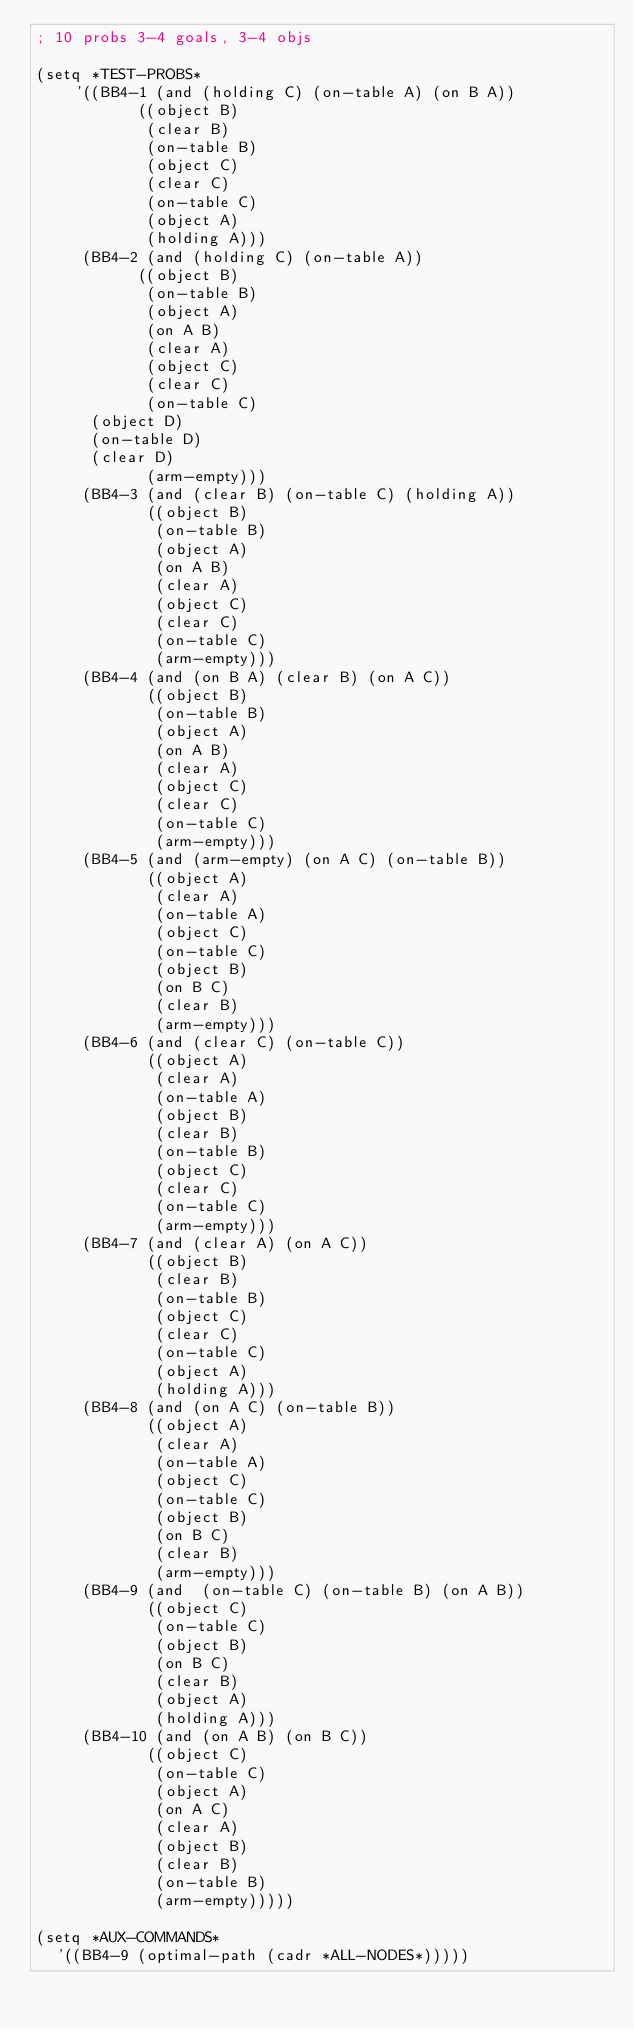Convert code to text. <code><loc_0><loc_0><loc_500><loc_500><_Lisp_>; 10 probs 3-4 goals, 3-4 objs

(setq *TEST-PROBS*
    '((BB4-1 (and (holding C) (on-table A) (on B A))
           ((object B)
            (clear B)
            (on-table B)
            (object C)
            (clear C)
            (on-table C)
            (object A)
            (holding A)))
     (BB4-2 (and (holding C) (on-table A))
           ((object B)
            (on-table B)
            (object A)
            (on A B)
            (clear A)
            (object C)
            (clear C)
            (on-table C)
	    (object D)
	    (on-table D)
	    (clear D)
            (arm-empty)))
     (BB4-3 (and (clear B) (on-table C) (holding A))
            ((object B)
             (on-table B)
             (object A)
             (on A B)
             (clear A)
             (object C)
             (clear C)
             (on-table C)
             (arm-empty)))
     (BB4-4 (and (on B A) (clear B) (on A C))
            ((object B)
             (on-table B)
             (object A)
             (on A B)
             (clear A)
             (object C)
             (clear C)
             (on-table C)
             (arm-empty)))
     (BB4-5 (and (arm-empty) (on A C) (on-table B))
            ((object A)
             (clear A)
             (on-table A)
             (object C)
             (on-table C)
             (object B)
             (on B C)
             (clear B)
             (arm-empty)))
     (BB4-6 (and (clear C) (on-table C))
            ((object A)
             (clear A)
             (on-table A)
             (object B)
             (clear B)
             (on-table B)
             (object C)
             (clear C)
             (on-table C)
             (arm-empty)))
     (BB4-7 (and (clear A) (on A C))
            ((object B)
             (clear B)
             (on-table B)
             (object C)
             (clear C)
             (on-table C)
             (object A)
             (holding A)))
     (BB4-8 (and (on A C) (on-table B))
            ((object A)
             (clear A)
             (on-table A)
             (object C)
             (on-table C)
             (object B)
             (on B C)
             (clear B)
             (arm-empty)))
     (BB4-9 (and  (on-table C) (on-table B) (on A B))
            ((object C)
             (on-table C)
             (object B)
             (on B C)
             (clear B)
             (object A)
             (holding A)))
     (BB4-10 (and (on A B) (on B C))
            ((object C)
             (on-table C)
             (object A)
             (on A C)
             (clear A)
             (object B)
             (clear B)
             (on-table B)
             (arm-empty)))))

(setq *AUX-COMMANDS*
  '((BB4-9 (optimal-path (cadr *ALL-NODES*)))))
</code> 